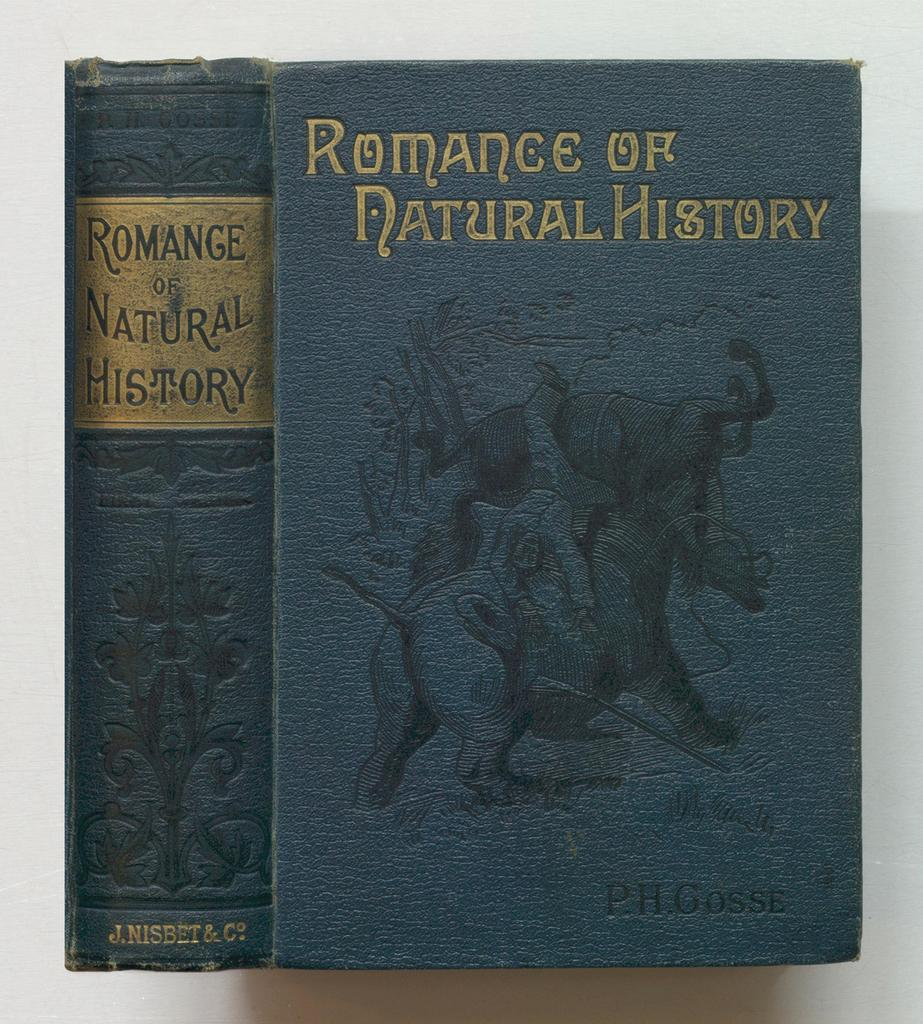<image>
Present a compact description of the photo's key features. A book whose title contains the word Natural is set against a white background. 